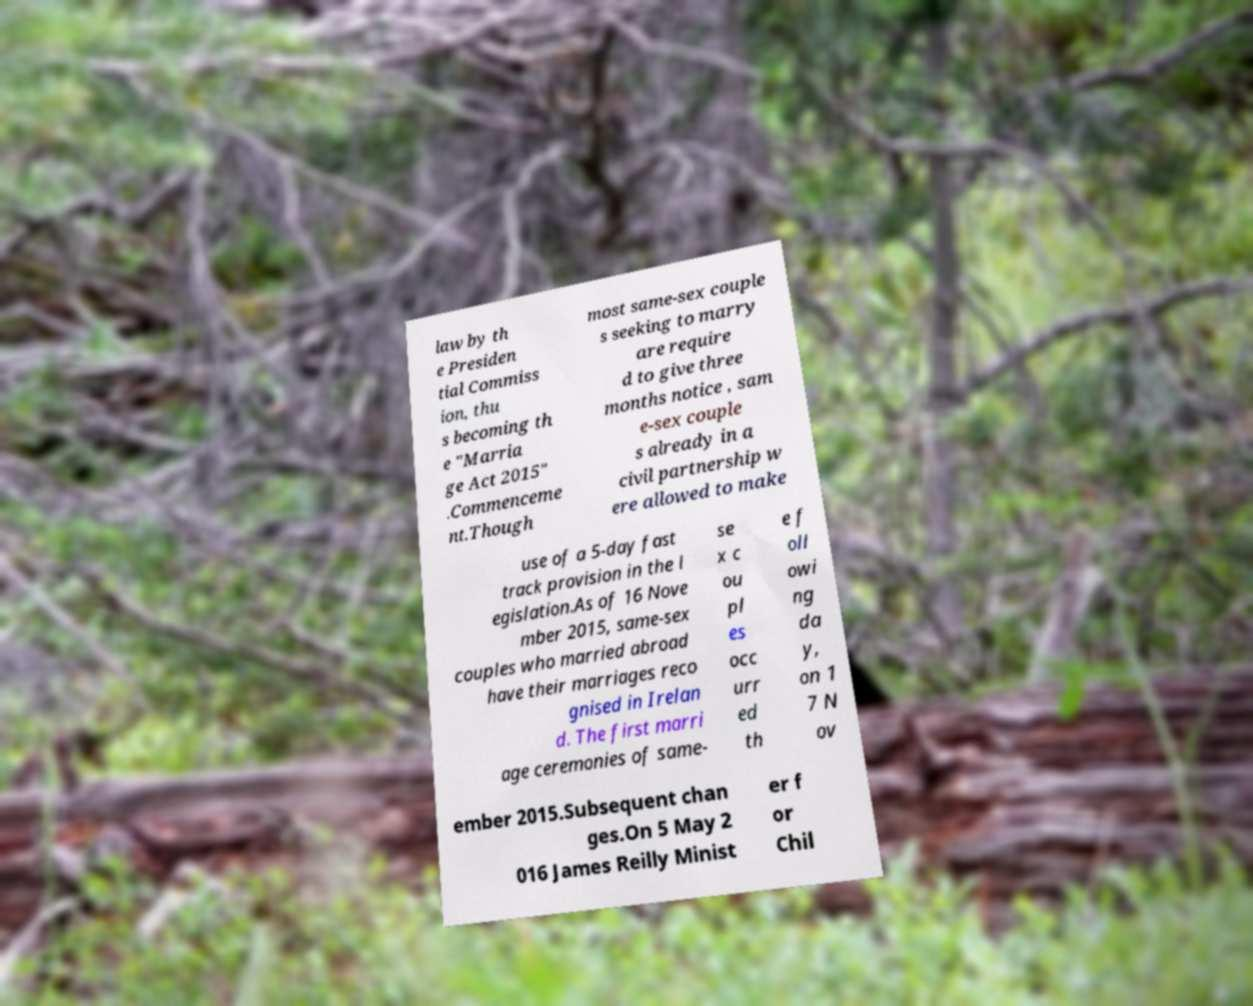What messages or text are displayed in this image? I need them in a readable, typed format. law by th e Presiden tial Commiss ion, thu s becoming th e "Marria ge Act 2015" .Commenceme nt.Though most same-sex couple s seeking to marry are require d to give three months notice , sam e-sex couple s already in a civil partnership w ere allowed to make use of a 5-day fast track provision in the l egislation.As of 16 Nove mber 2015, same-sex couples who married abroad have their marriages reco gnised in Irelan d. The first marri age ceremonies of same- se x c ou pl es occ urr ed th e f oll owi ng da y, on 1 7 N ov ember 2015.Subsequent chan ges.On 5 May 2 016 James Reilly Minist er f or Chil 